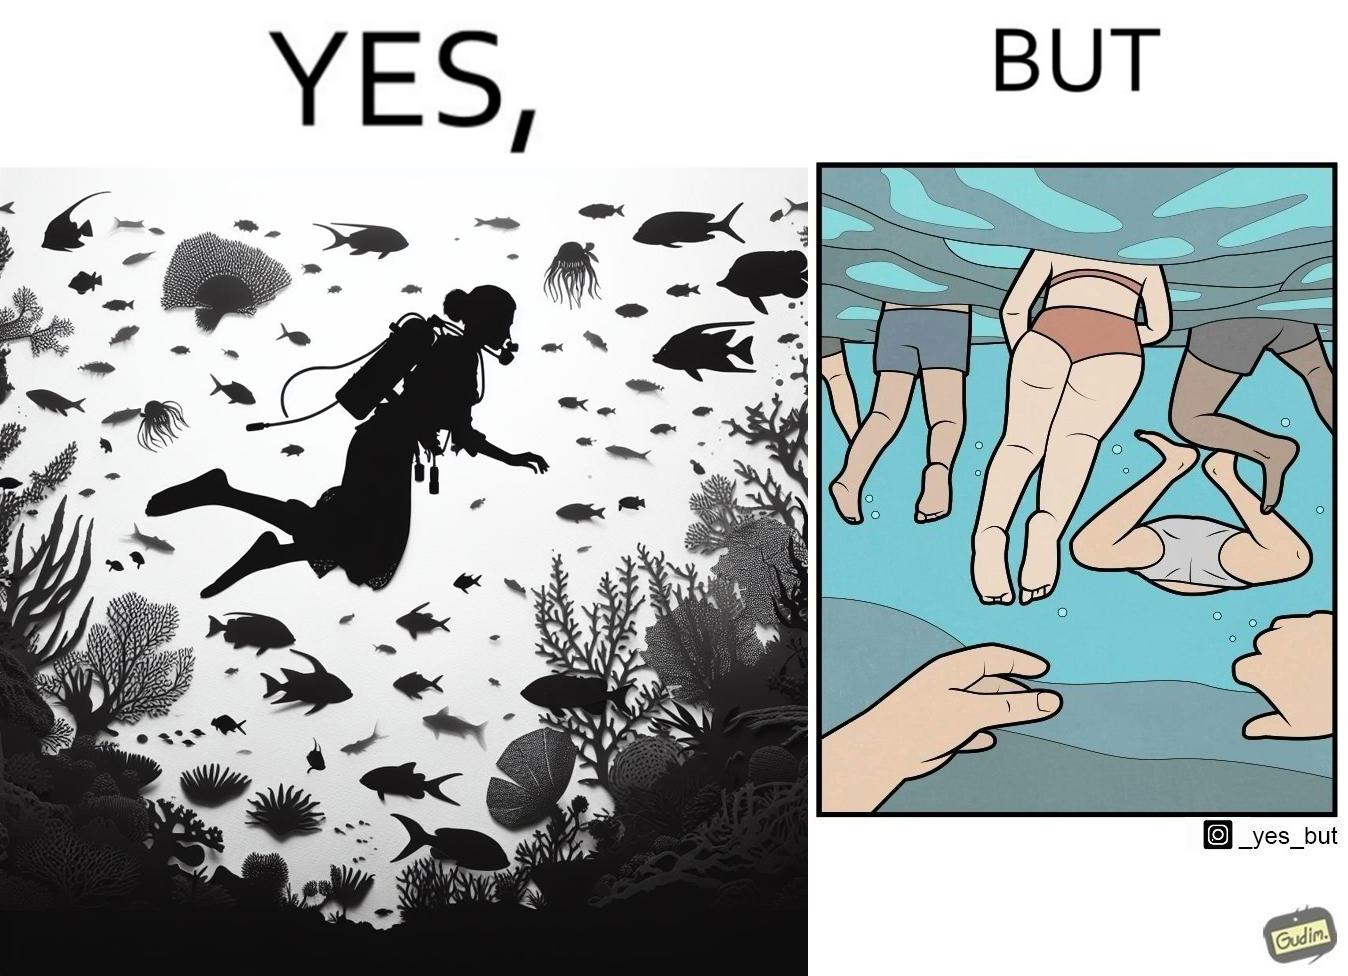Is this a satirical image? Yes, this image is satirical. 